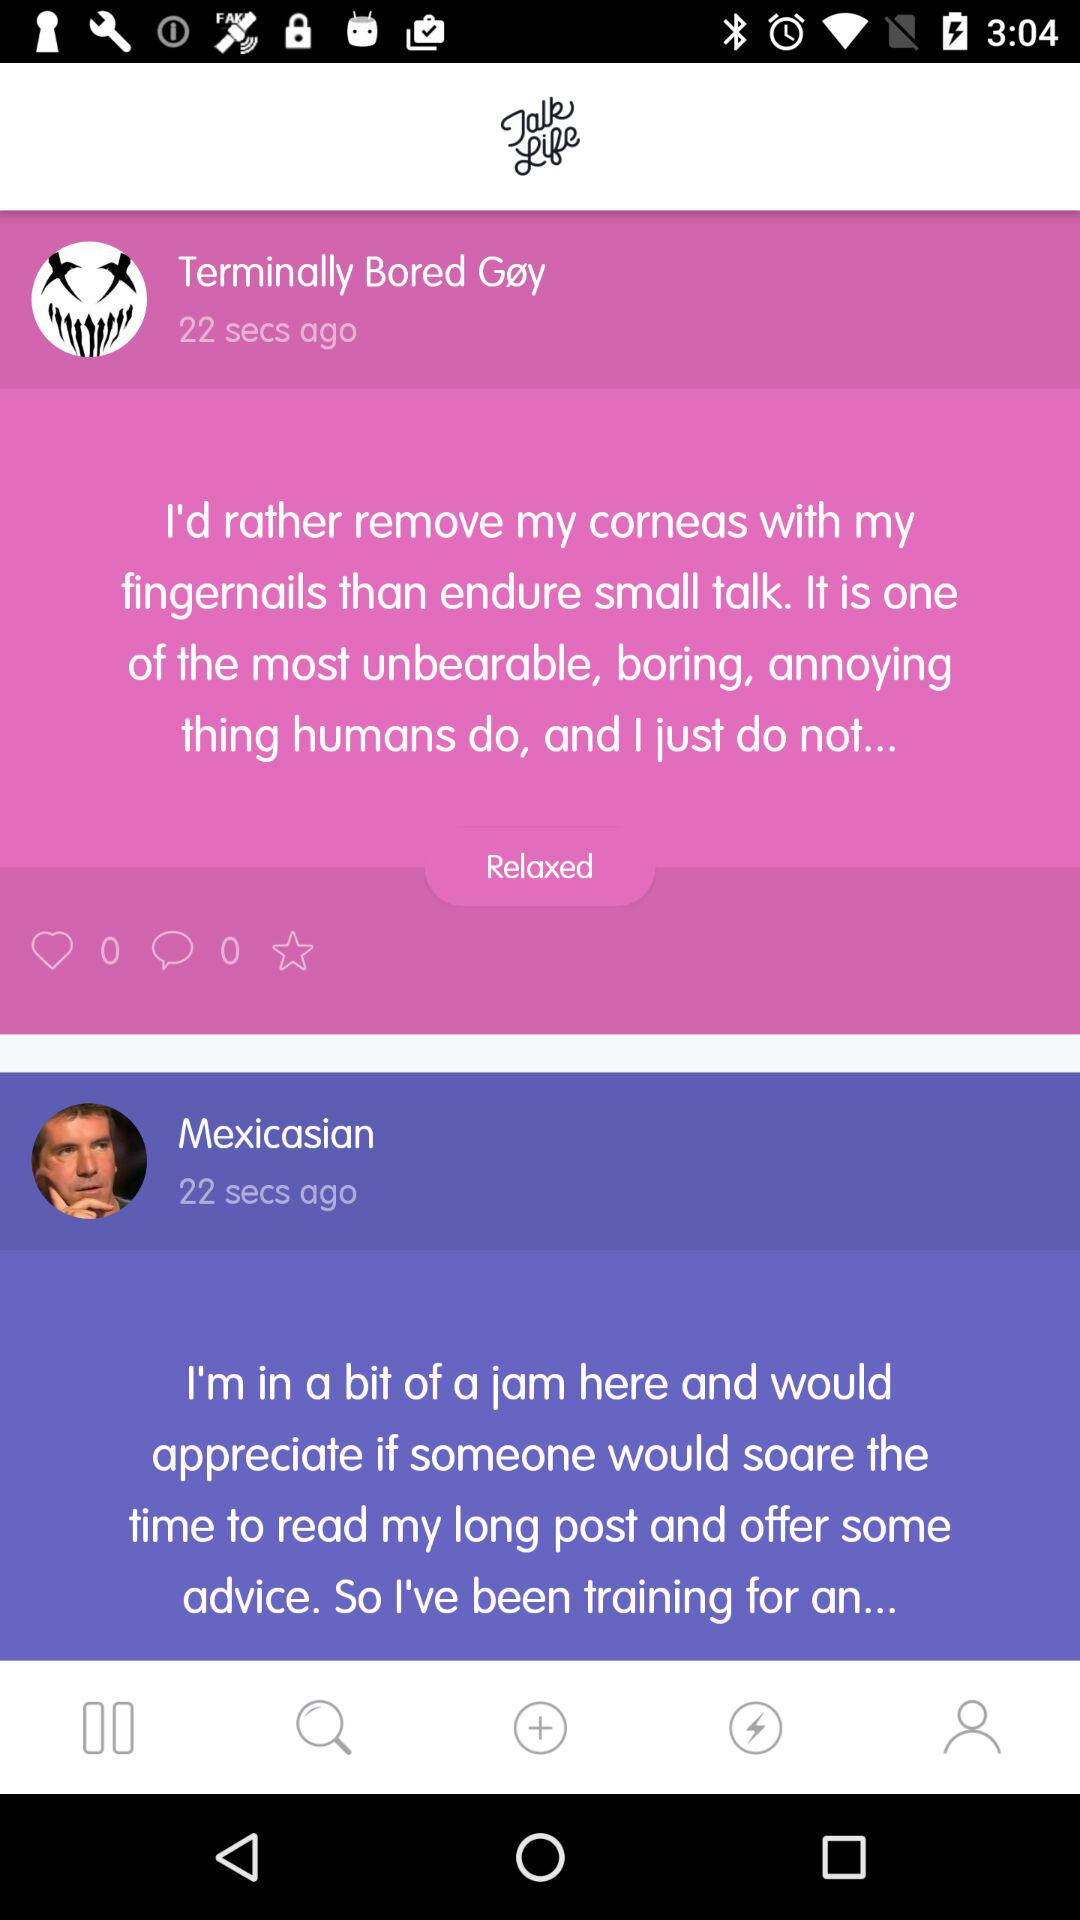How long ago was the post posted by "Terminally Bored Gøy"? The post was posted 22 seconds ago. 